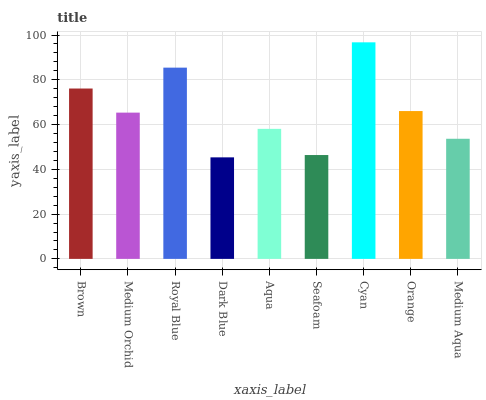Is Dark Blue the minimum?
Answer yes or no. Yes. Is Cyan the maximum?
Answer yes or no. Yes. Is Medium Orchid the minimum?
Answer yes or no. No. Is Medium Orchid the maximum?
Answer yes or no. No. Is Brown greater than Medium Orchid?
Answer yes or no. Yes. Is Medium Orchid less than Brown?
Answer yes or no. Yes. Is Medium Orchid greater than Brown?
Answer yes or no. No. Is Brown less than Medium Orchid?
Answer yes or no. No. Is Medium Orchid the high median?
Answer yes or no. Yes. Is Medium Orchid the low median?
Answer yes or no. Yes. Is Orange the high median?
Answer yes or no. No. Is Orange the low median?
Answer yes or no. No. 